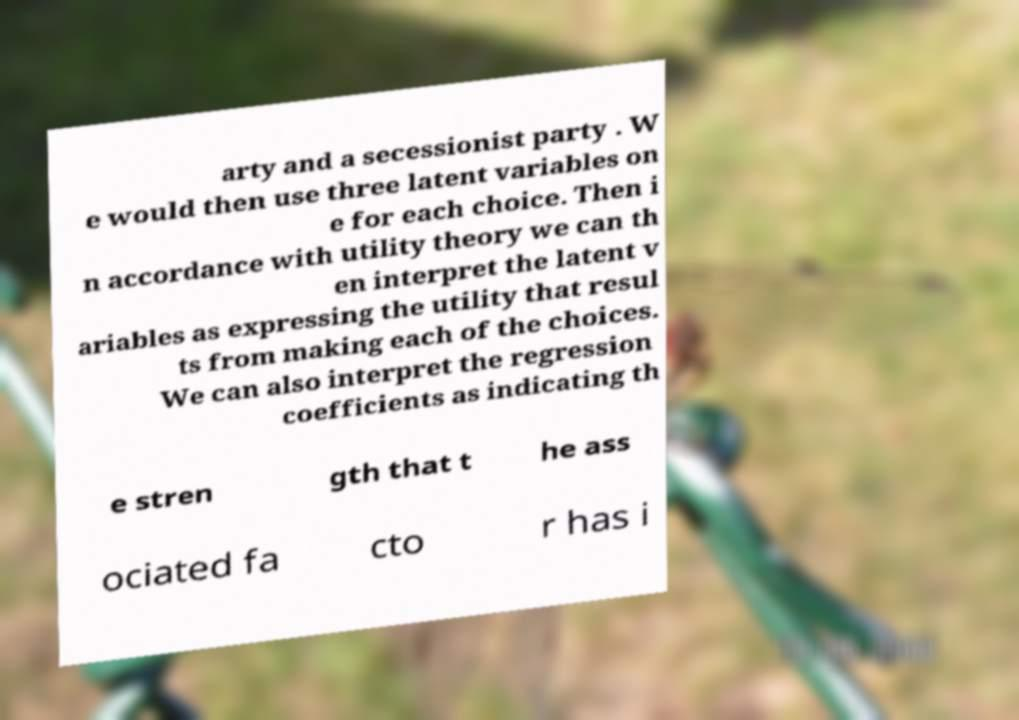Could you extract and type out the text from this image? arty and a secessionist party . W e would then use three latent variables on e for each choice. Then i n accordance with utility theory we can th en interpret the latent v ariables as expressing the utility that resul ts from making each of the choices. We can also interpret the regression coefficients as indicating th e stren gth that t he ass ociated fa cto r has i 